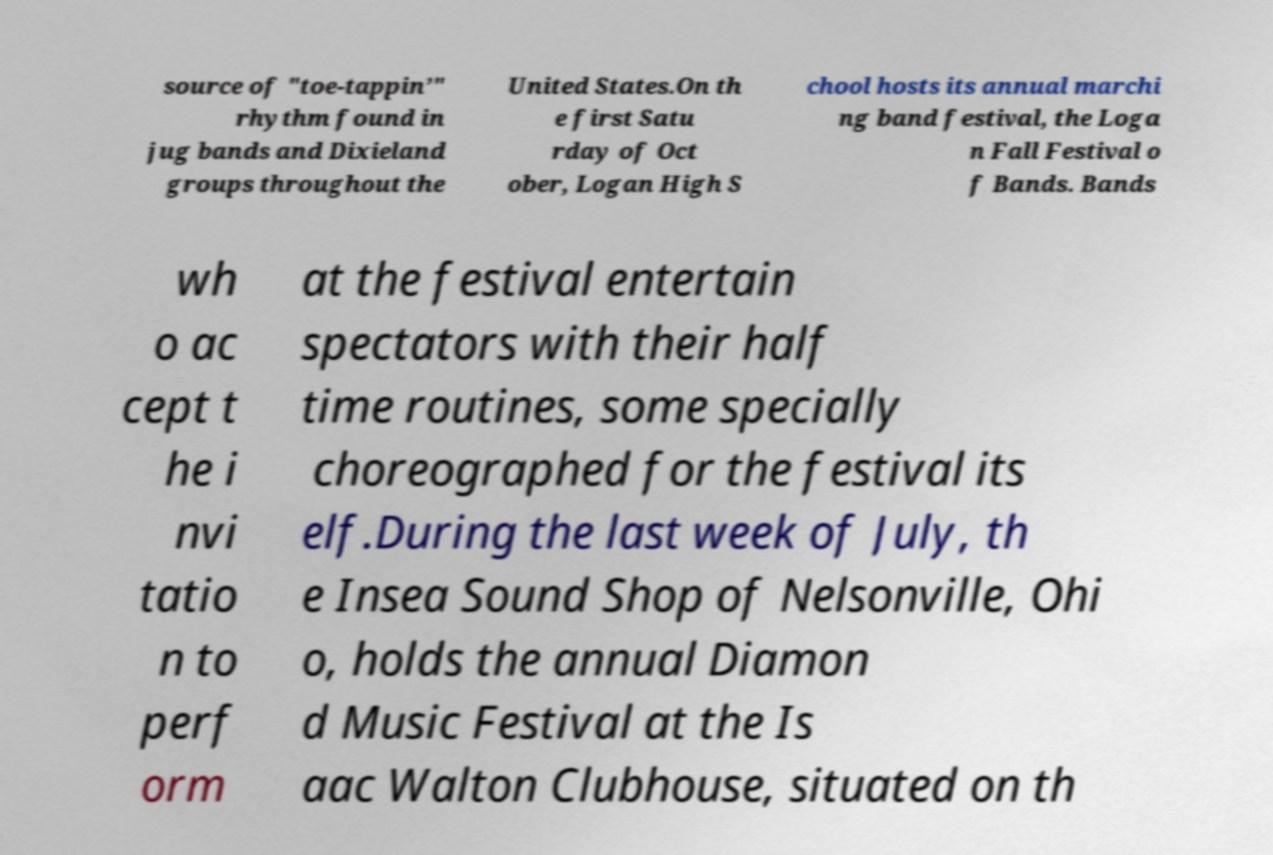For documentation purposes, I need the text within this image transcribed. Could you provide that? source of "toe-tappin’" rhythm found in jug bands and Dixieland groups throughout the United States.On th e first Satu rday of Oct ober, Logan High S chool hosts its annual marchi ng band festival, the Loga n Fall Festival o f Bands. Bands wh o ac cept t he i nvi tatio n to perf orm at the festival entertain spectators with their half time routines, some specially choreographed for the festival its elf.During the last week of July, th e Insea Sound Shop of Nelsonville, Ohi o, holds the annual Diamon d Music Festival at the Is aac Walton Clubhouse, situated on th 